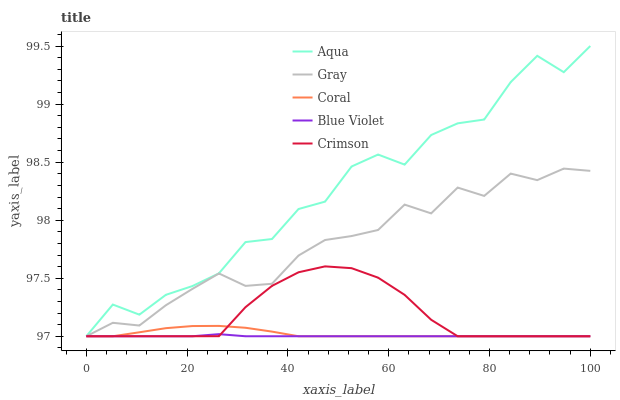Does Blue Violet have the minimum area under the curve?
Answer yes or no. Yes. Does Aqua have the maximum area under the curve?
Answer yes or no. Yes. Does Gray have the minimum area under the curve?
Answer yes or no. No. Does Gray have the maximum area under the curve?
Answer yes or no. No. Is Blue Violet the smoothest?
Answer yes or no. Yes. Is Aqua the roughest?
Answer yes or no. Yes. Is Gray the smoothest?
Answer yes or no. No. Is Gray the roughest?
Answer yes or no. No. Does Crimson have the lowest value?
Answer yes or no. Yes. Does Aqua have the highest value?
Answer yes or no. Yes. Does Gray have the highest value?
Answer yes or no. No. Does Coral intersect Blue Violet?
Answer yes or no. Yes. Is Coral less than Blue Violet?
Answer yes or no. No. Is Coral greater than Blue Violet?
Answer yes or no. No. 